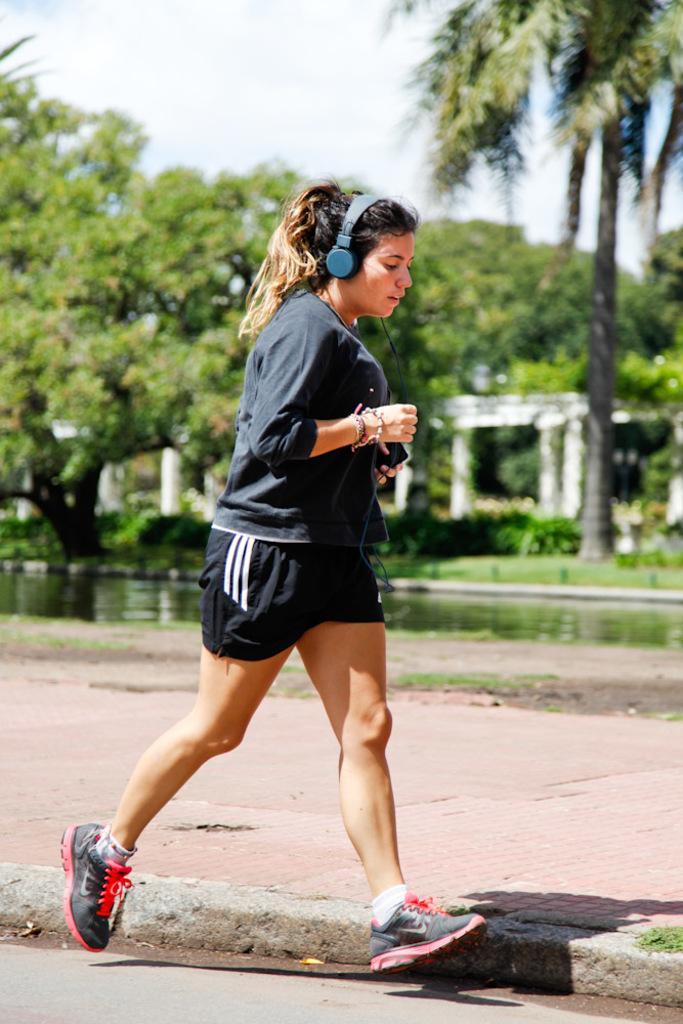Could you give a brief overview of what you see in this image? In this picture we can see a woman is running, she is holding a mobile phone, we can see headphones on her head, in the background we can see some trees, there is water in the middle, there is the sky at the top of the picture. 